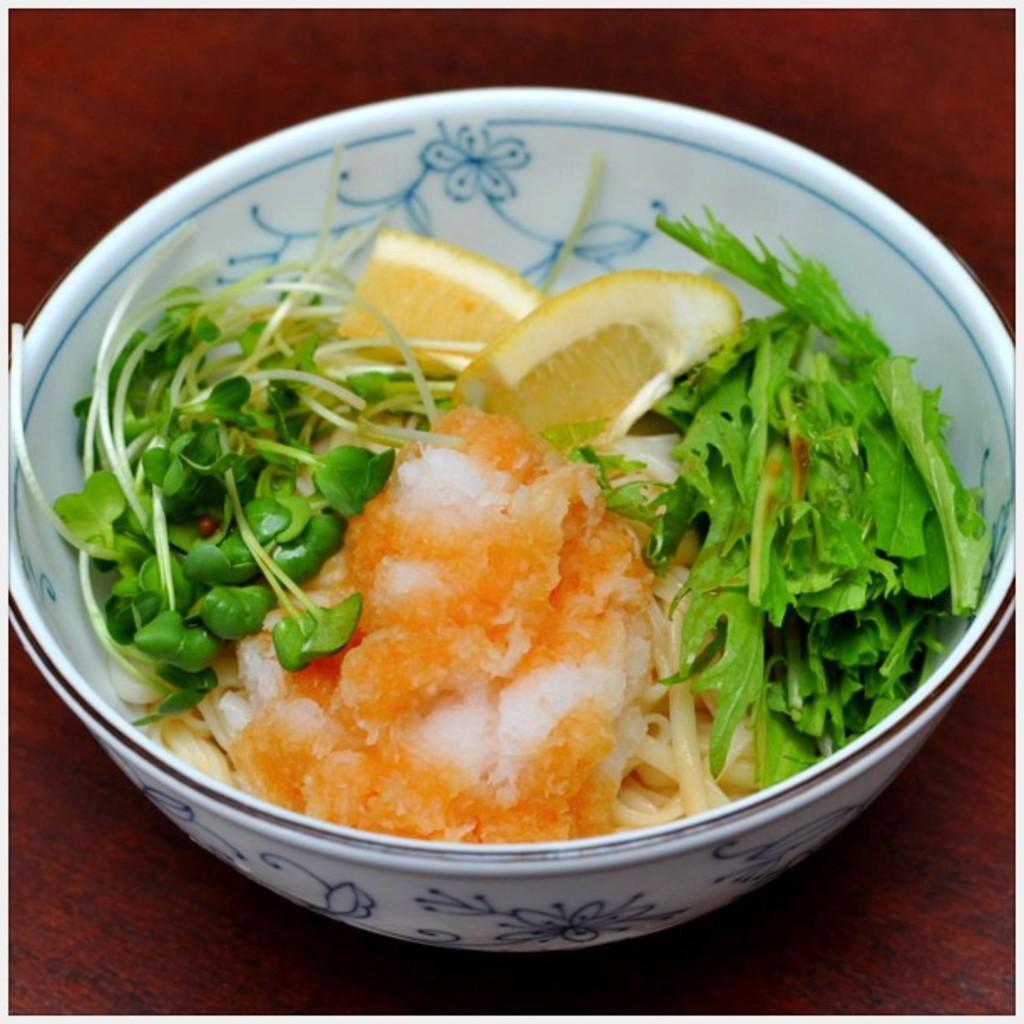Can you describe this image briefly? In this image, we can see a table, on that table, we can see a bowl with some fruits and vegetables. 